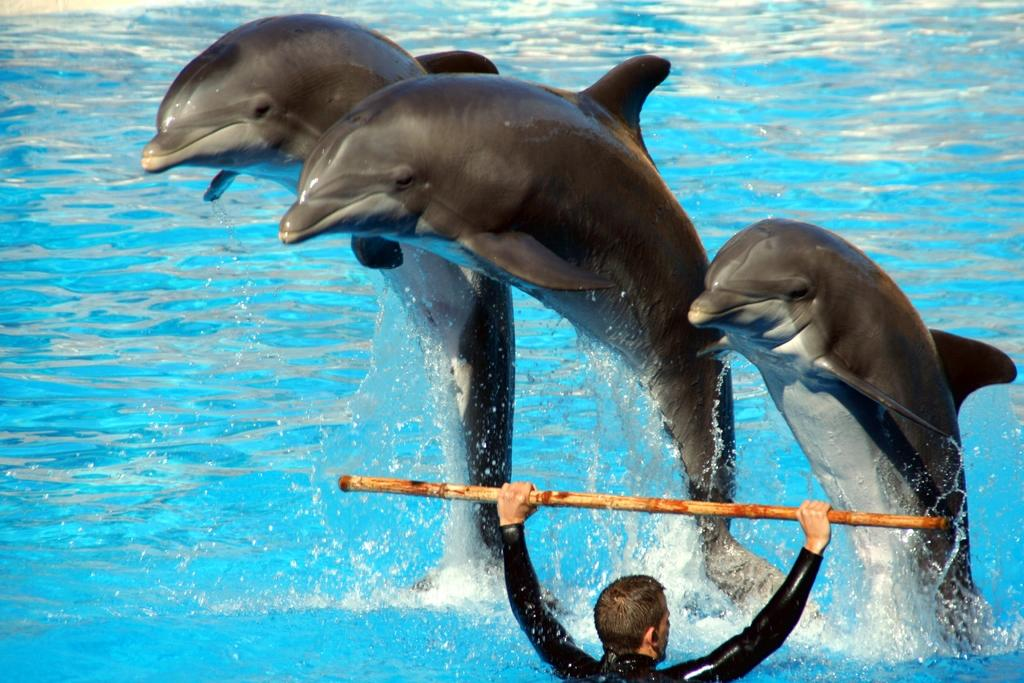What animals can be seen in the image? There are dolphins in the image. What is the primary element in which the dolphins are situated? There is water visible in the image, and the dolphins are in the water. What is the person in the image holding with his hands? The person is holding a stick with his hands in the image. What type of division is being performed by the dolphins in the image? There is no division being performed by the dolphins in the image; they are simply swimming in the water. What trade is being conducted between the dolphins and the person in the image? There is no trade being conducted between the dolphins and the person in the image; they are not interacting with each other. 